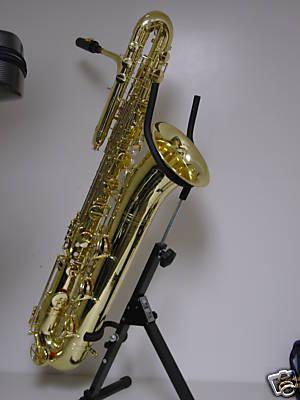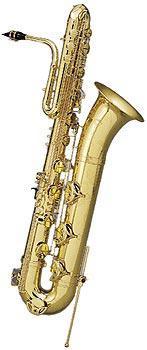The first image is the image on the left, the second image is the image on the right. Analyze the images presented: Is the assertion "The left image features a saxophone on a stand tilting rightward." valid? Answer yes or no. Yes. The first image is the image on the left, the second image is the image on the right. Analyze the images presented: Is the assertion "At least one mouthpiece is black." valid? Answer yes or no. Yes. 